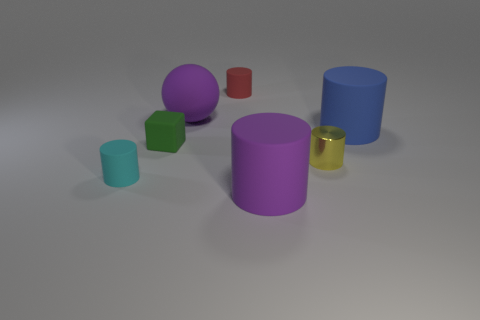Are there any other things that are made of the same material as the tiny yellow object?
Provide a succinct answer. No. What number of objects are blue rubber objects or tiny yellow rubber blocks?
Ensure brevity in your answer.  1. There is a tiny thing that is on the right side of the purple thing that is in front of the blue thing; what is its shape?
Give a very brief answer. Cylinder. There is a small object that is left of the tiny green rubber block; is its shape the same as the blue matte object?
Provide a short and direct response. Yes. There is a red thing that is the same material as the tiny cyan cylinder; what size is it?
Offer a very short reply. Small. How many things are things right of the small cyan rubber thing or purple rubber things that are behind the tiny green rubber thing?
Provide a succinct answer. 6. Are there the same number of small green matte things that are to the right of the small green block and big purple cylinders that are on the right side of the purple cylinder?
Ensure brevity in your answer.  Yes. What is the color of the small rubber cylinder on the left side of the tiny red cylinder?
Give a very brief answer. Cyan. There is a matte ball; does it have the same color as the large rubber object that is in front of the tiny cyan cylinder?
Offer a terse response. Yes. Is the number of tiny green rubber blocks less than the number of big gray metal blocks?
Ensure brevity in your answer.  No. 